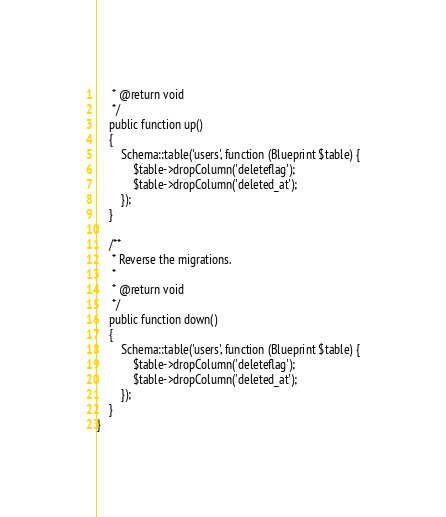<code> <loc_0><loc_0><loc_500><loc_500><_PHP_>     * @return void
     */
    public function up()
    {
        Schema::table('users', function (Blueprint $table) {
            $table->dropColumn('deleteflag'); 
            $table->dropColumn('deleted_at');  
        });
    }

    /**
     * Reverse the migrations.
     *
     * @return void
     */
    public function down()
    {
        Schema::table('users', function (Blueprint $table) {
            $table->dropColumn('deleteflag'); 
            $table->dropColumn('deleted_at');  
        });
    }
}
</code> 